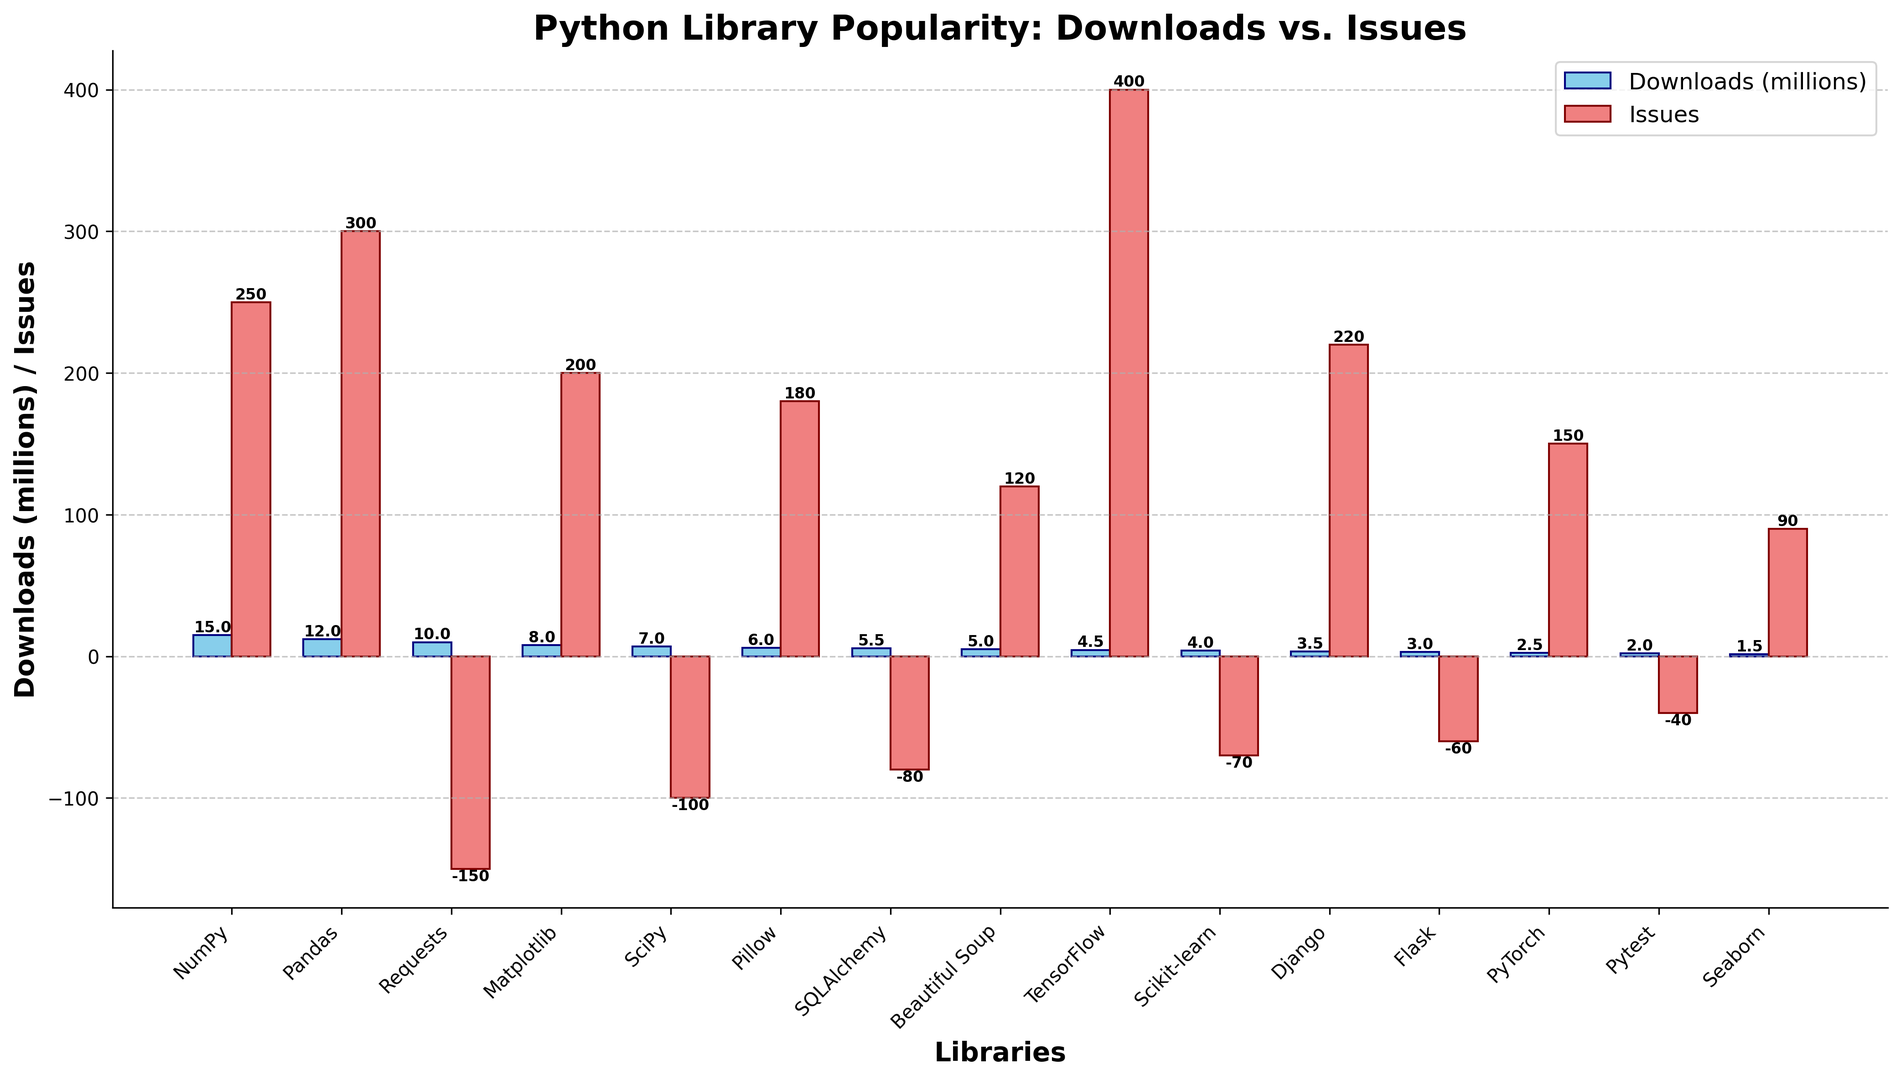Which library has the highest number of downloads? By observing the height of the blue bars representing downloads, the highest bar corresponds to NumPy.
Answer: NumPy Which library has reported the most number of issues? By checking the height of the red bars that represent issues, the tallest red bar belongs to TensorFlow.
Answer: TensorFlow How many libraries have negative issue values? By identifying the red bars that extend below the x-axis, we see that 5 libraries (Requests, SciPy, SQLAlchemy, Scikit-learn, Flask) have negative issue values.
Answer: 5 Which library has more downloads: Pandas or Matplotlib? Compare the heights of the blue bars for Pandas and Matplotlib; the Pandas bar is higher.
Answer: Pandas What is the combined number of downloads (in millions) for SQLAlchemy and Pillow? Add the values of SQLAlchemy (5.5 million) and Pillow (6 million) from the blue bars: 5.5 + 6 = 11.5 million.
Answer: 11.5 Which library has fewer issues: Beautiful Soup or PyTorch? Comparing the heights of the red bars for Beautiful Soup and PyTorch, the Beautiful Soup bar is shorter.
Answer: Beautiful Soup How many more downloads (in millions) does Django have compared to Flask? Django has 3.5 million downloads and Flask has 3 million, so the difference is 3.5 - 3 = 0.5 million.
Answer: 0.5 Which library has the lowest number of downloads but positive issues? By identifying the shortest blue bar among those with a positive red bar, Seaborn has the lowest downloads with positive issues.
Answer: Seaborn What is the average number of downloads (in millions) for TensorFlow, Scikit-learn, and PyTorch? Sum the download values: 4.5 (TensorFlow) + 4 (Scikit-learn) + 2.5 (PyTorch) = 11, then divide by 3: 11 / 3 ≈ 3.67 million.
Answer: 3.67 What is the difference between the number of issues reported for NumPy and Pandas? Subtract the number of issues for NumPy (250) from Pandas (300): 300 - 250 = 50.
Answer: 50 